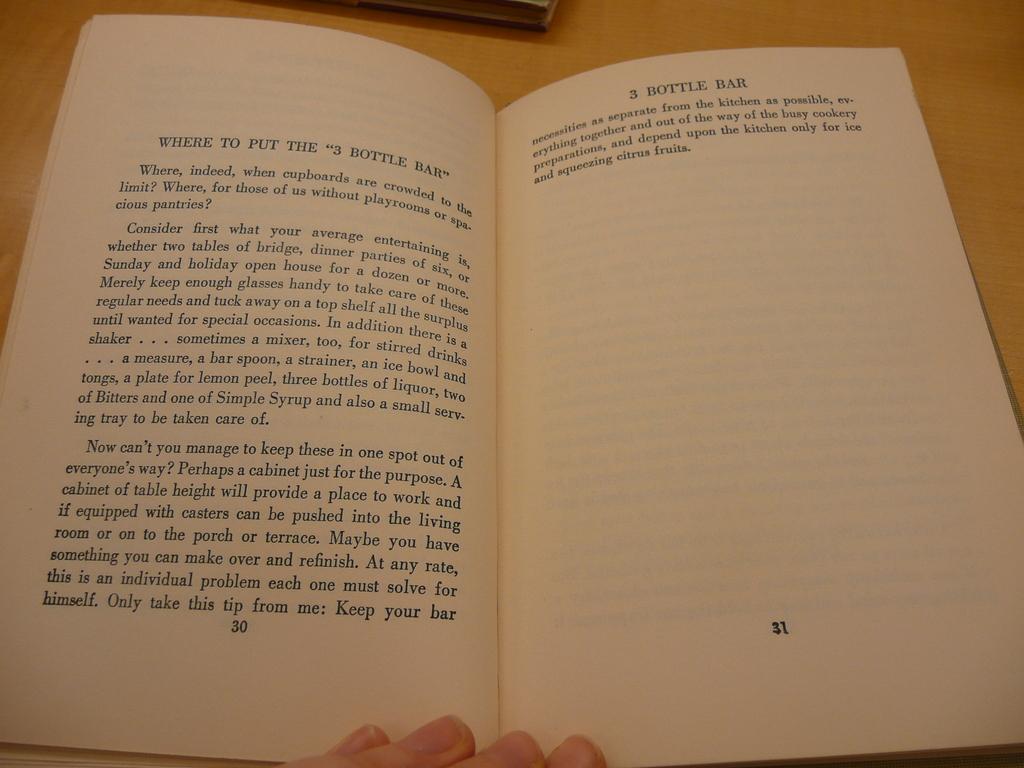What is the name of this book?
Ensure brevity in your answer.  3 bottle bar. 